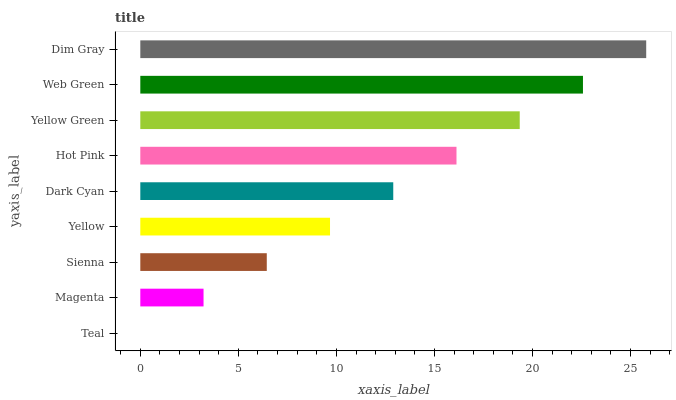Is Teal the minimum?
Answer yes or no. Yes. Is Dim Gray the maximum?
Answer yes or no. Yes. Is Magenta the minimum?
Answer yes or no. No. Is Magenta the maximum?
Answer yes or no. No. Is Magenta greater than Teal?
Answer yes or no. Yes. Is Teal less than Magenta?
Answer yes or no. Yes. Is Teal greater than Magenta?
Answer yes or no. No. Is Magenta less than Teal?
Answer yes or no. No. Is Dark Cyan the high median?
Answer yes or no. Yes. Is Dark Cyan the low median?
Answer yes or no. Yes. Is Yellow the high median?
Answer yes or no. No. Is Sienna the low median?
Answer yes or no. No. 